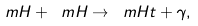Convert formula to latex. <formula><loc_0><loc_0><loc_500><loc_500>\ m H + \ m H \rightarrow \ m H t + \gamma ,</formula> 